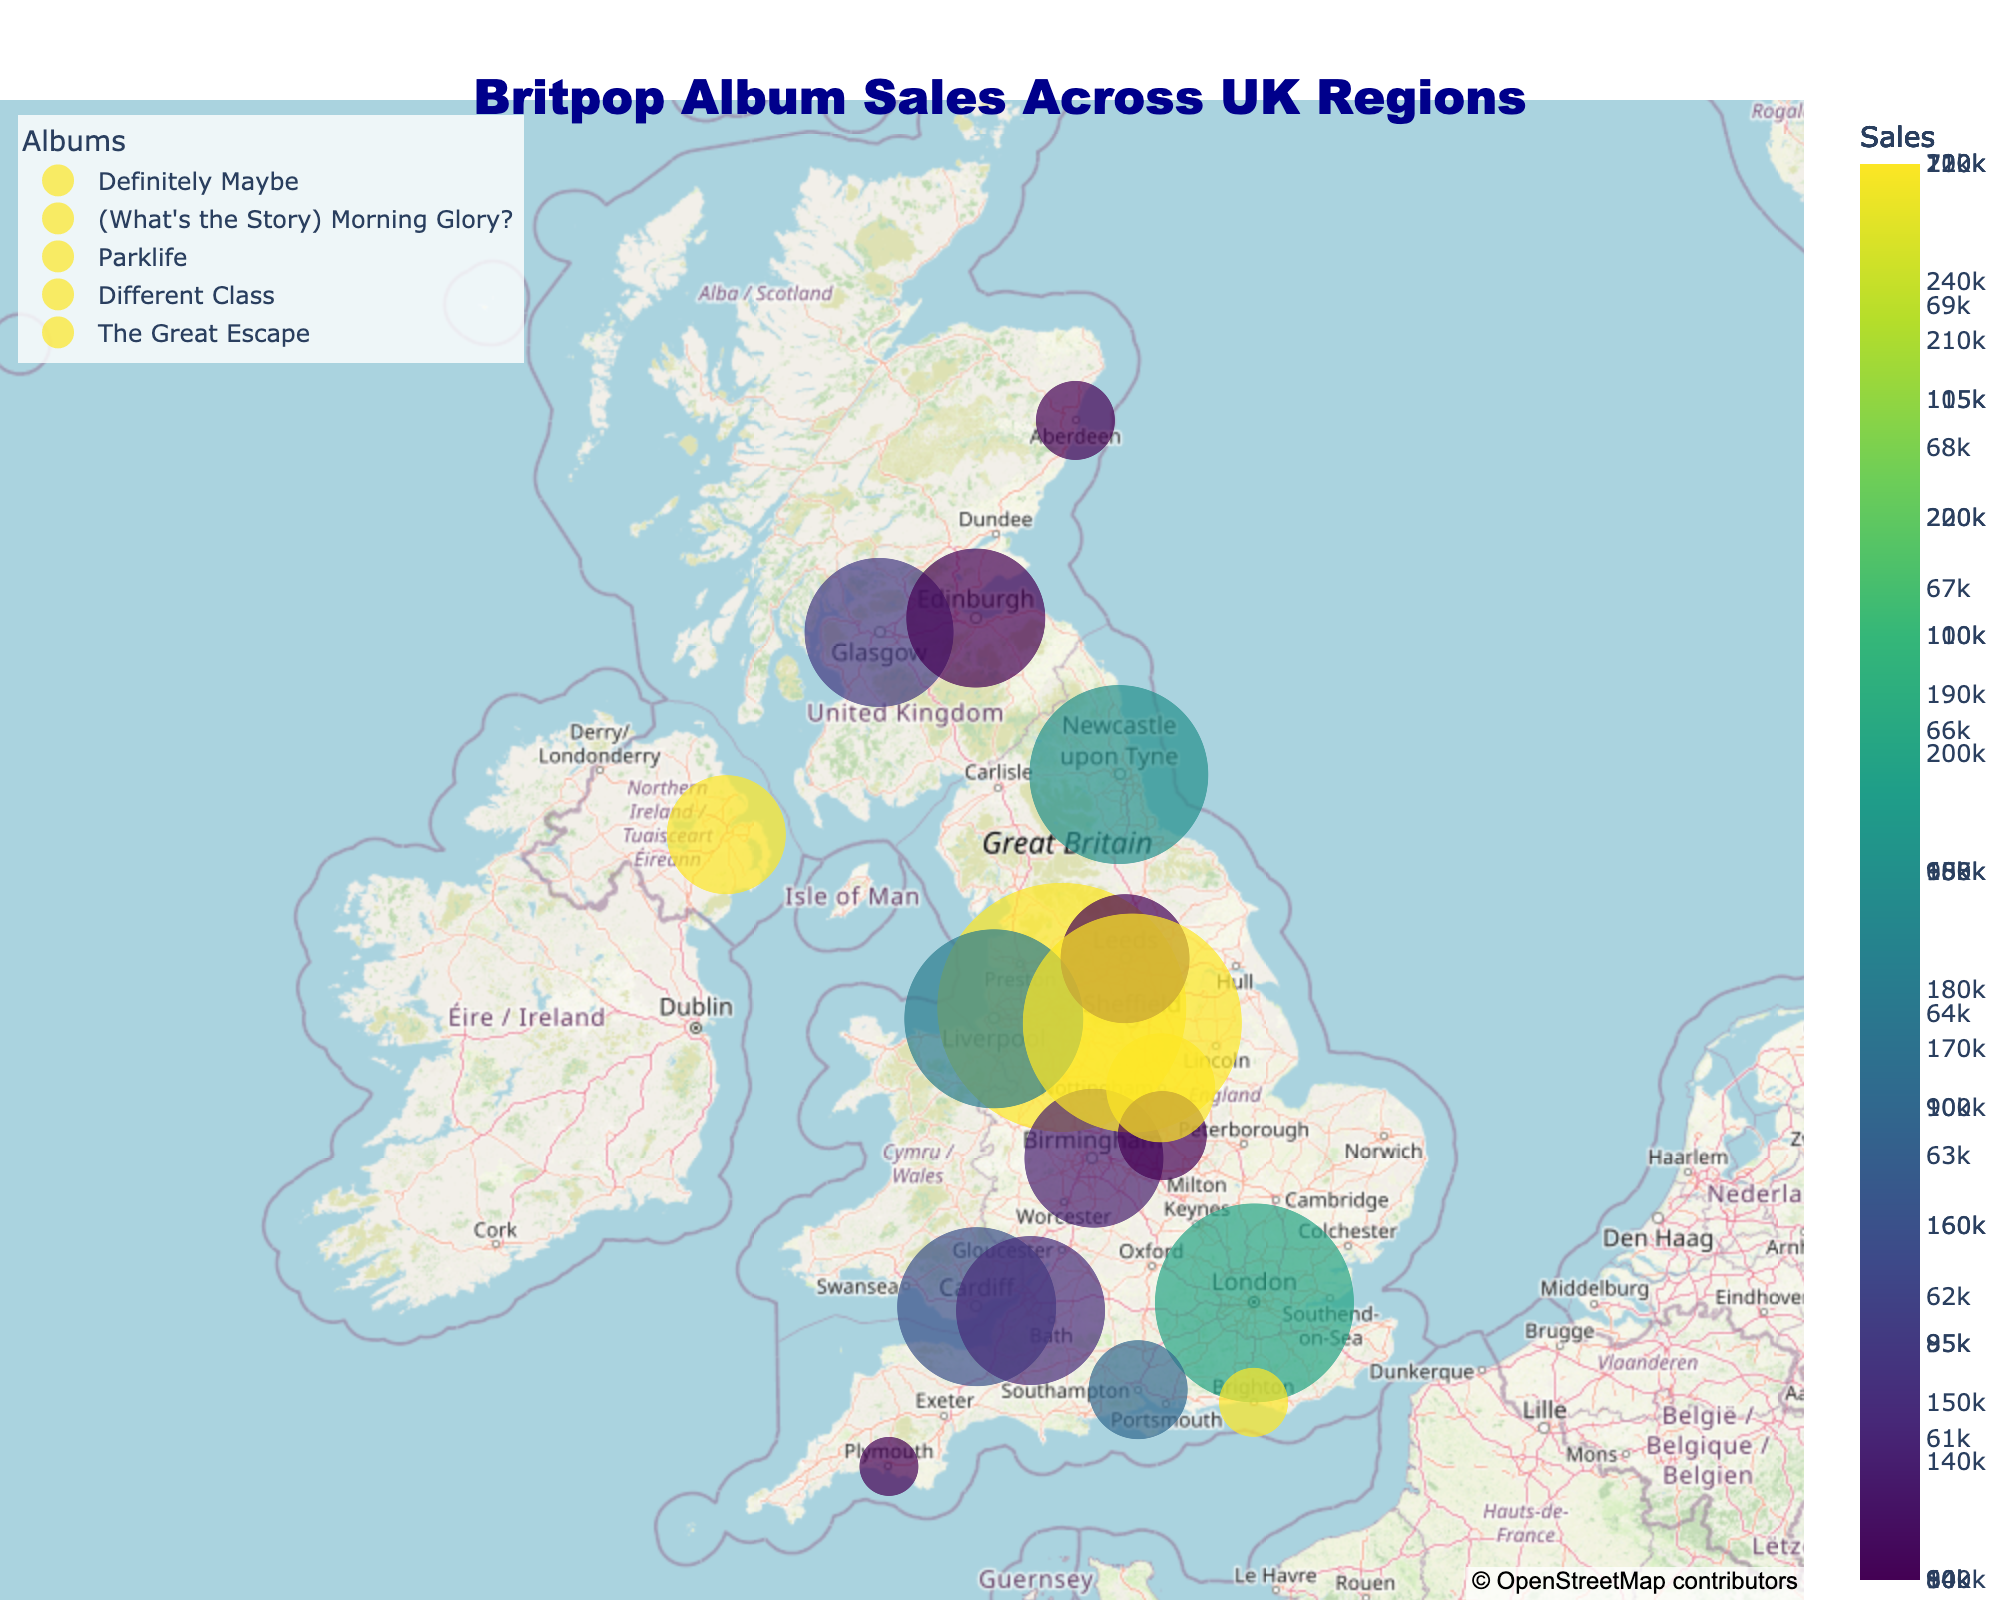How many regions in the UK had sales for the album "Definitely Maybe"? To find the number of regions that had sales for "Definitely Maybe," we can count the number of unique regions listed for that album on the plot. There are five regions: Greater Manchester, London, Liverpool, Glasgow, and Birmingham.
Answer: 5 Which region showed the highest sales for "(What's the Story) Morning Glory?" To determine the region with the highest sales for "(What's the Story) Morning Glory?," identify the largest marker representing that album. The largest marker is in Sheffield with 220,000 sales.
Answer: Sheffield What is the total sales for the album "Parklife" from the available regions? Summing the sales for "Parklife" involves adding the sales from all the regions with this album: Belfast (120,000) + Southampton (100,000) + Leicester (90,000) = 310,000.
Answer: 310,000 How do sales of "Definitely Maybe" in Liverpool compare to those in Glasgow? By comparing the sales markers for "Definitely Maybe" in Liverpool (180,000) and Glasgow (150,000), we see that Liverpool has higher sales.
Answer: Liverpool is higher Which album has sales in the region furthest north? To find the northernmost region, look for the region with the highest latitude. Aberdeen (57.1497) is the northernmost, which corresponds to "Different Class" with 80,000 sales.
Answer: Different Class What's the average number of sales for all regions of the album "Different Class"? Calculate the average of the sales for "Different Class" by summing the sales in Nottingham (110,000) and Aberdeen (80,000) and dividing by the number of regions, which is 2. (110,000 + 80,000) / 2 = 95,000.
Answer: 95,000 